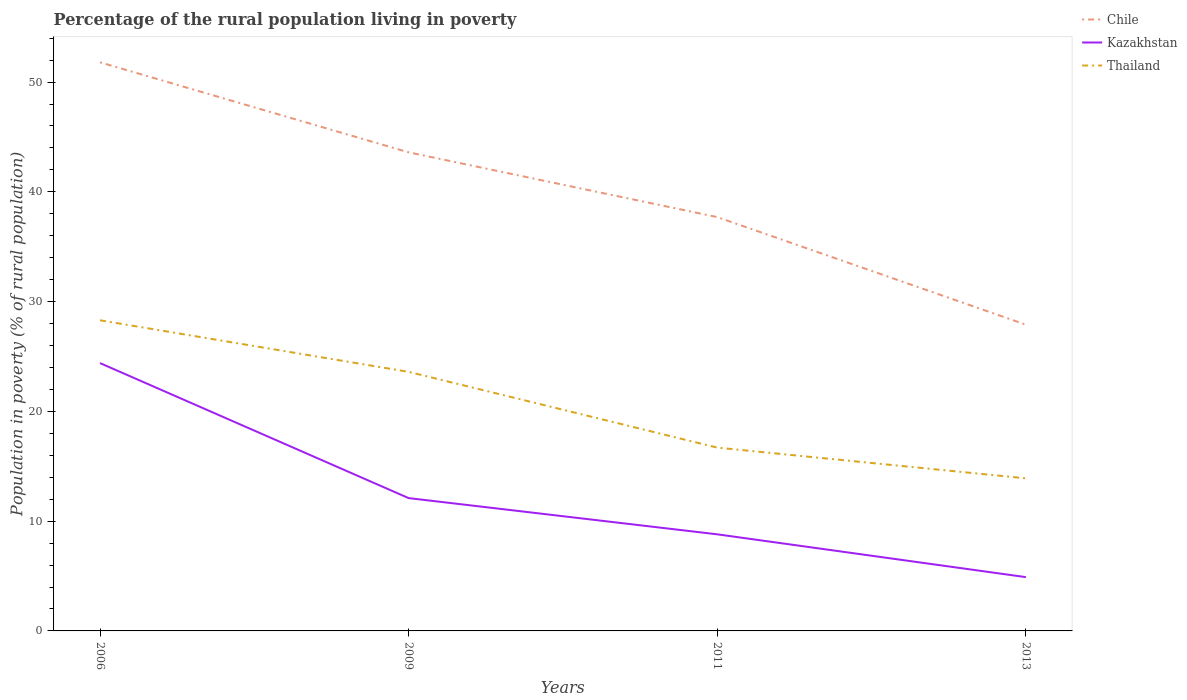Is the number of lines equal to the number of legend labels?
Provide a short and direct response. Yes. Across all years, what is the maximum percentage of the rural population living in poverty in Kazakhstan?
Make the answer very short. 4.9. What is the total percentage of the rural population living in poverty in Chile in the graph?
Your answer should be compact. 9.8. How many years are there in the graph?
Provide a succinct answer. 4. Are the values on the major ticks of Y-axis written in scientific E-notation?
Offer a terse response. No. Does the graph contain any zero values?
Provide a succinct answer. No. Where does the legend appear in the graph?
Keep it short and to the point. Top right. How many legend labels are there?
Give a very brief answer. 3. How are the legend labels stacked?
Give a very brief answer. Vertical. What is the title of the graph?
Ensure brevity in your answer.  Percentage of the rural population living in poverty. What is the label or title of the Y-axis?
Provide a succinct answer. Population in poverty (% of rural population). What is the Population in poverty (% of rural population) of Chile in 2006?
Offer a terse response. 51.8. What is the Population in poverty (% of rural population) in Kazakhstan in 2006?
Your answer should be very brief. 24.4. What is the Population in poverty (% of rural population) of Thailand in 2006?
Your answer should be compact. 28.3. What is the Population in poverty (% of rural population) of Chile in 2009?
Offer a terse response. 43.6. What is the Population in poverty (% of rural population) of Thailand in 2009?
Make the answer very short. 23.6. What is the Population in poverty (% of rural population) in Chile in 2011?
Offer a very short reply. 37.7. What is the Population in poverty (% of rural population) of Kazakhstan in 2011?
Keep it short and to the point. 8.8. What is the Population in poverty (% of rural population) in Chile in 2013?
Your answer should be very brief. 27.9. What is the Population in poverty (% of rural population) of Kazakhstan in 2013?
Ensure brevity in your answer.  4.9. What is the Population in poverty (% of rural population) of Thailand in 2013?
Provide a short and direct response. 13.9. Across all years, what is the maximum Population in poverty (% of rural population) in Chile?
Provide a short and direct response. 51.8. Across all years, what is the maximum Population in poverty (% of rural population) in Kazakhstan?
Provide a short and direct response. 24.4. Across all years, what is the maximum Population in poverty (% of rural population) of Thailand?
Give a very brief answer. 28.3. Across all years, what is the minimum Population in poverty (% of rural population) of Chile?
Provide a short and direct response. 27.9. Across all years, what is the minimum Population in poverty (% of rural population) of Kazakhstan?
Your answer should be very brief. 4.9. What is the total Population in poverty (% of rural population) of Chile in the graph?
Your answer should be compact. 161. What is the total Population in poverty (% of rural population) of Kazakhstan in the graph?
Make the answer very short. 50.2. What is the total Population in poverty (% of rural population) in Thailand in the graph?
Give a very brief answer. 82.5. What is the difference between the Population in poverty (% of rural population) of Chile in 2006 and that in 2009?
Your answer should be compact. 8.2. What is the difference between the Population in poverty (% of rural population) of Kazakhstan in 2006 and that in 2009?
Provide a short and direct response. 12.3. What is the difference between the Population in poverty (% of rural population) in Chile in 2006 and that in 2011?
Your answer should be compact. 14.1. What is the difference between the Population in poverty (% of rural population) in Kazakhstan in 2006 and that in 2011?
Ensure brevity in your answer.  15.6. What is the difference between the Population in poverty (% of rural population) of Chile in 2006 and that in 2013?
Offer a very short reply. 23.9. What is the difference between the Population in poverty (% of rural population) in Kazakhstan in 2006 and that in 2013?
Your answer should be very brief. 19.5. What is the difference between the Population in poverty (% of rural population) of Thailand in 2006 and that in 2013?
Your answer should be very brief. 14.4. What is the difference between the Population in poverty (% of rural population) in Chile in 2009 and that in 2011?
Give a very brief answer. 5.9. What is the difference between the Population in poverty (% of rural population) in Kazakhstan in 2009 and that in 2011?
Your response must be concise. 3.3. What is the difference between the Population in poverty (% of rural population) in Kazakhstan in 2009 and that in 2013?
Give a very brief answer. 7.2. What is the difference between the Population in poverty (% of rural population) of Kazakhstan in 2011 and that in 2013?
Give a very brief answer. 3.9. What is the difference between the Population in poverty (% of rural population) in Thailand in 2011 and that in 2013?
Offer a terse response. 2.8. What is the difference between the Population in poverty (% of rural population) in Chile in 2006 and the Population in poverty (% of rural population) in Kazakhstan in 2009?
Make the answer very short. 39.7. What is the difference between the Population in poverty (% of rural population) in Chile in 2006 and the Population in poverty (% of rural population) in Thailand in 2009?
Make the answer very short. 28.2. What is the difference between the Population in poverty (% of rural population) in Chile in 2006 and the Population in poverty (% of rural population) in Thailand in 2011?
Make the answer very short. 35.1. What is the difference between the Population in poverty (% of rural population) of Kazakhstan in 2006 and the Population in poverty (% of rural population) of Thailand in 2011?
Give a very brief answer. 7.7. What is the difference between the Population in poverty (% of rural population) in Chile in 2006 and the Population in poverty (% of rural population) in Kazakhstan in 2013?
Keep it short and to the point. 46.9. What is the difference between the Population in poverty (% of rural population) in Chile in 2006 and the Population in poverty (% of rural population) in Thailand in 2013?
Provide a succinct answer. 37.9. What is the difference between the Population in poverty (% of rural population) in Chile in 2009 and the Population in poverty (% of rural population) in Kazakhstan in 2011?
Make the answer very short. 34.8. What is the difference between the Population in poverty (% of rural population) in Chile in 2009 and the Population in poverty (% of rural population) in Thailand in 2011?
Give a very brief answer. 26.9. What is the difference between the Population in poverty (% of rural population) in Chile in 2009 and the Population in poverty (% of rural population) in Kazakhstan in 2013?
Your answer should be very brief. 38.7. What is the difference between the Population in poverty (% of rural population) in Chile in 2009 and the Population in poverty (% of rural population) in Thailand in 2013?
Provide a short and direct response. 29.7. What is the difference between the Population in poverty (% of rural population) in Chile in 2011 and the Population in poverty (% of rural population) in Kazakhstan in 2013?
Keep it short and to the point. 32.8. What is the difference between the Population in poverty (% of rural population) in Chile in 2011 and the Population in poverty (% of rural population) in Thailand in 2013?
Offer a very short reply. 23.8. What is the difference between the Population in poverty (% of rural population) in Kazakhstan in 2011 and the Population in poverty (% of rural population) in Thailand in 2013?
Keep it short and to the point. -5.1. What is the average Population in poverty (% of rural population) in Chile per year?
Ensure brevity in your answer.  40.25. What is the average Population in poverty (% of rural population) of Kazakhstan per year?
Provide a short and direct response. 12.55. What is the average Population in poverty (% of rural population) in Thailand per year?
Offer a terse response. 20.62. In the year 2006, what is the difference between the Population in poverty (% of rural population) of Chile and Population in poverty (% of rural population) of Kazakhstan?
Give a very brief answer. 27.4. In the year 2006, what is the difference between the Population in poverty (% of rural population) of Chile and Population in poverty (% of rural population) of Thailand?
Your response must be concise. 23.5. In the year 2006, what is the difference between the Population in poverty (% of rural population) of Kazakhstan and Population in poverty (% of rural population) of Thailand?
Provide a succinct answer. -3.9. In the year 2009, what is the difference between the Population in poverty (% of rural population) of Chile and Population in poverty (% of rural population) of Kazakhstan?
Keep it short and to the point. 31.5. In the year 2009, what is the difference between the Population in poverty (% of rural population) of Kazakhstan and Population in poverty (% of rural population) of Thailand?
Your answer should be very brief. -11.5. In the year 2011, what is the difference between the Population in poverty (% of rural population) of Chile and Population in poverty (% of rural population) of Kazakhstan?
Give a very brief answer. 28.9. In the year 2011, what is the difference between the Population in poverty (% of rural population) in Chile and Population in poverty (% of rural population) in Thailand?
Your answer should be very brief. 21. In the year 2011, what is the difference between the Population in poverty (% of rural population) of Kazakhstan and Population in poverty (% of rural population) of Thailand?
Ensure brevity in your answer.  -7.9. In the year 2013, what is the difference between the Population in poverty (% of rural population) of Chile and Population in poverty (% of rural population) of Thailand?
Make the answer very short. 14. In the year 2013, what is the difference between the Population in poverty (% of rural population) in Kazakhstan and Population in poverty (% of rural population) in Thailand?
Provide a succinct answer. -9. What is the ratio of the Population in poverty (% of rural population) of Chile in 2006 to that in 2009?
Give a very brief answer. 1.19. What is the ratio of the Population in poverty (% of rural population) in Kazakhstan in 2006 to that in 2009?
Offer a terse response. 2.02. What is the ratio of the Population in poverty (% of rural population) of Thailand in 2006 to that in 2009?
Your answer should be compact. 1.2. What is the ratio of the Population in poverty (% of rural population) in Chile in 2006 to that in 2011?
Ensure brevity in your answer.  1.37. What is the ratio of the Population in poverty (% of rural population) of Kazakhstan in 2006 to that in 2011?
Your answer should be very brief. 2.77. What is the ratio of the Population in poverty (% of rural population) in Thailand in 2006 to that in 2011?
Offer a terse response. 1.69. What is the ratio of the Population in poverty (% of rural population) in Chile in 2006 to that in 2013?
Make the answer very short. 1.86. What is the ratio of the Population in poverty (% of rural population) in Kazakhstan in 2006 to that in 2013?
Offer a very short reply. 4.98. What is the ratio of the Population in poverty (% of rural population) of Thailand in 2006 to that in 2013?
Offer a very short reply. 2.04. What is the ratio of the Population in poverty (% of rural population) of Chile in 2009 to that in 2011?
Ensure brevity in your answer.  1.16. What is the ratio of the Population in poverty (% of rural population) of Kazakhstan in 2009 to that in 2011?
Keep it short and to the point. 1.38. What is the ratio of the Population in poverty (% of rural population) of Thailand in 2009 to that in 2011?
Your response must be concise. 1.41. What is the ratio of the Population in poverty (% of rural population) of Chile in 2009 to that in 2013?
Ensure brevity in your answer.  1.56. What is the ratio of the Population in poverty (% of rural population) in Kazakhstan in 2009 to that in 2013?
Provide a short and direct response. 2.47. What is the ratio of the Population in poverty (% of rural population) of Thailand in 2009 to that in 2013?
Ensure brevity in your answer.  1.7. What is the ratio of the Population in poverty (% of rural population) of Chile in 2011 to that in 2013?
Make the answer very short. 1.35. What is the ratio of the Population in poverty (% of rural population) of Kazakhstan in 2011 to that in 2013?
Ensure brevity in your answer.  1.8. What is the ratio of the Population in poverty (% of rural population) of Thailand in 2011 to that in 2013?
Provide a succinct answer. 1.2. What is the difference between the highest and the second highest Population in poverty (% of rural population) of Chile?
Your answer should be very brief. 8.2. What is the difference between the highest and the second highest Population in poverty (% of rural population) in Thailand?
Keep it short and to the point. 4.7. What is the difference between the highest and the lowest Population in poverty (% of rural population) in Chile?
Offer a terse response. 23.9. What is the difference between the highest and the lowest Population in poverty (% of rural population) of Kazakhstan?
Offer a very short reply. 19.5. 